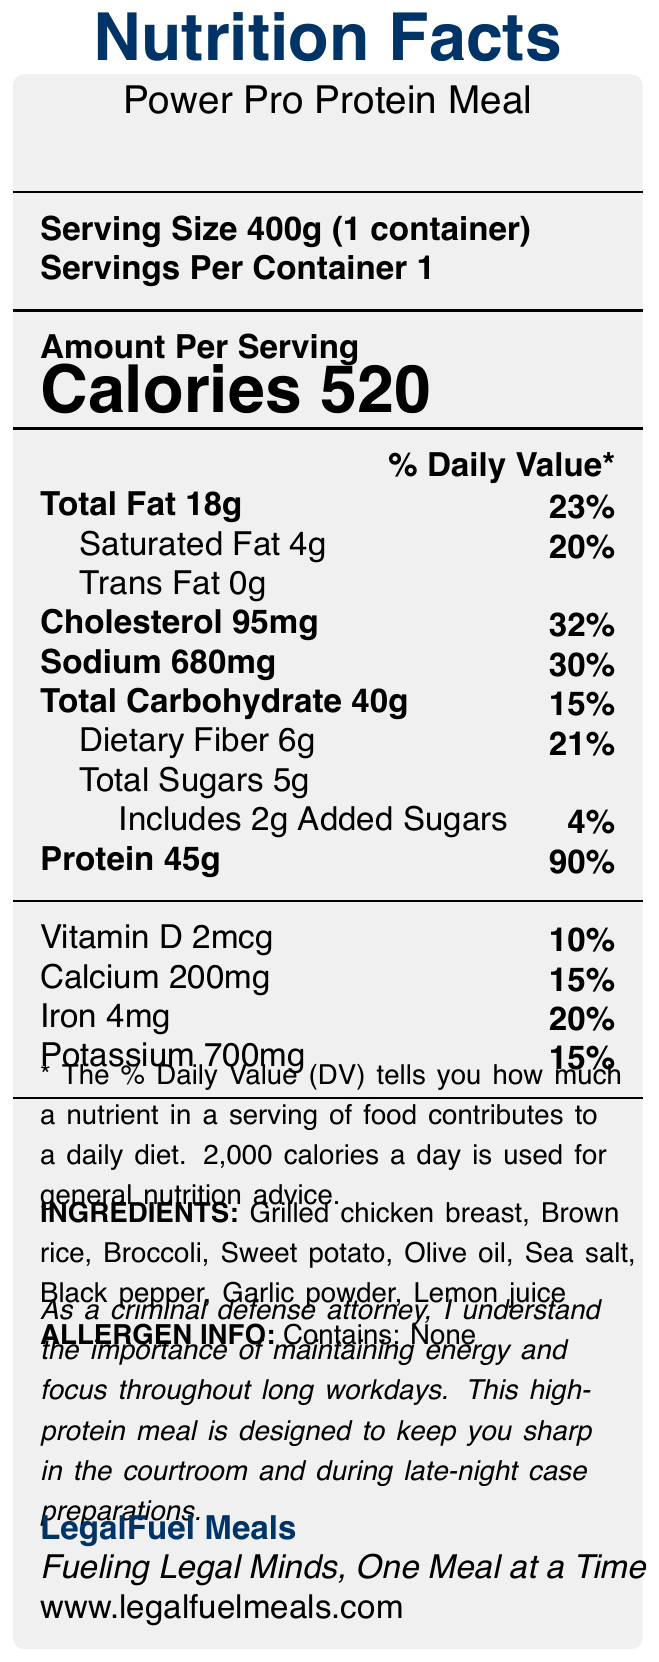what is the serving size of the Power Pro Protein Meal? The serving size is clearly stated as "400g (1 container)" at the top of the Nutrition Facts label.
Answer: 400g (1 container) how many calories are there per serving? The document shows "Calories 520" under the "Amount Per Serving" section.
Answer: 520 what is the total fat content, and what percentage of the daily value does it represent? The total fat content listed is "18g" and it represents "23%" of the daily value.
Answer: 18g, 23% how much protein does each Power Pro Protein Meal provide? The nutrition facts state that there are "45g" of protein per serving.
Answer: 45g how much dietary fiber is in one serving? The nutritional information indicates that there is "6g" of dietary fiber in each serving.
Answer: 6g what percentage of the daily value of calcium does one meal provide? The document lists calcium as "200mg" with a daily value percentage of "15%".
Answer: 15% what are the main ingredients used in the Power Pro Protein Meal? The ingredients section toward the bottom of the document lists these items as the components of the meal.
Answer: Grilled chicken breast, Brown rice, Broccoli, Sweet potato, Olive oil, Sea salt, Black pepper, Garlic powder, Lemon juice does the meal contain any allergens? The allergen information states "Contains: None," indicating that the meal does not contain any allergens.
Answer: No what is the percentage of daily iron intake provided by one serving of this meal? The iron content is listed as "4mg" and it represents "20%" of the daily value.
Answer: 20% which of the following nutrients in the Power Pro Protein Meal has the highest percentage of daily value? A. Total Fat B. Sodium C. Protein D. Dietary Fiber The protein content represents "90%" of the daily value, which is higher than the others listed.
Answer: C. Protein how many grams of added sugars are in the meal? A. 6g B. 2g C. 5g D. 10g The nutrition facts list added sugars as "2g," which is the correct answer.
Answer: B. 2g is the Power Pro Protein Meal designed for people with strong physical activity needs? The legal note mentions the meal is designed for criminal defense attorneys to maintain energy and focus throughout long workdays, not explicitly for those with strong physical activity needs.
Answer: No summarize the entire document. The Nutrition Facts label provides comprehensive nutritional information and ingredient details for a high-protein meal aimed at busy professionals. It emphasizes the importance of energy and focus, particularly for legal professionals.
Answer: The document is a Nutrition Facts label for "Power Pro Protein Meal" by LegalFuel Meals. It details the serving size, calories, and nutritional content, including fats, cholesterol, sodium, carbohydrates, sugars, proteins, and various vitamins and minerals. It lists ingredients such as grilled chicken breast and brown rice, confirms no allergens, and includes a legal note emphasizing the meal’s role in maintaining energy and focus for busy professionals. The brand’s slogan and website are also provided. what is the name of the chef who created the recipe for the Power Pro Protein Meal? The label does not provide any information about the chef who created the recipe for the meal.
Answer: Cannot be determined 